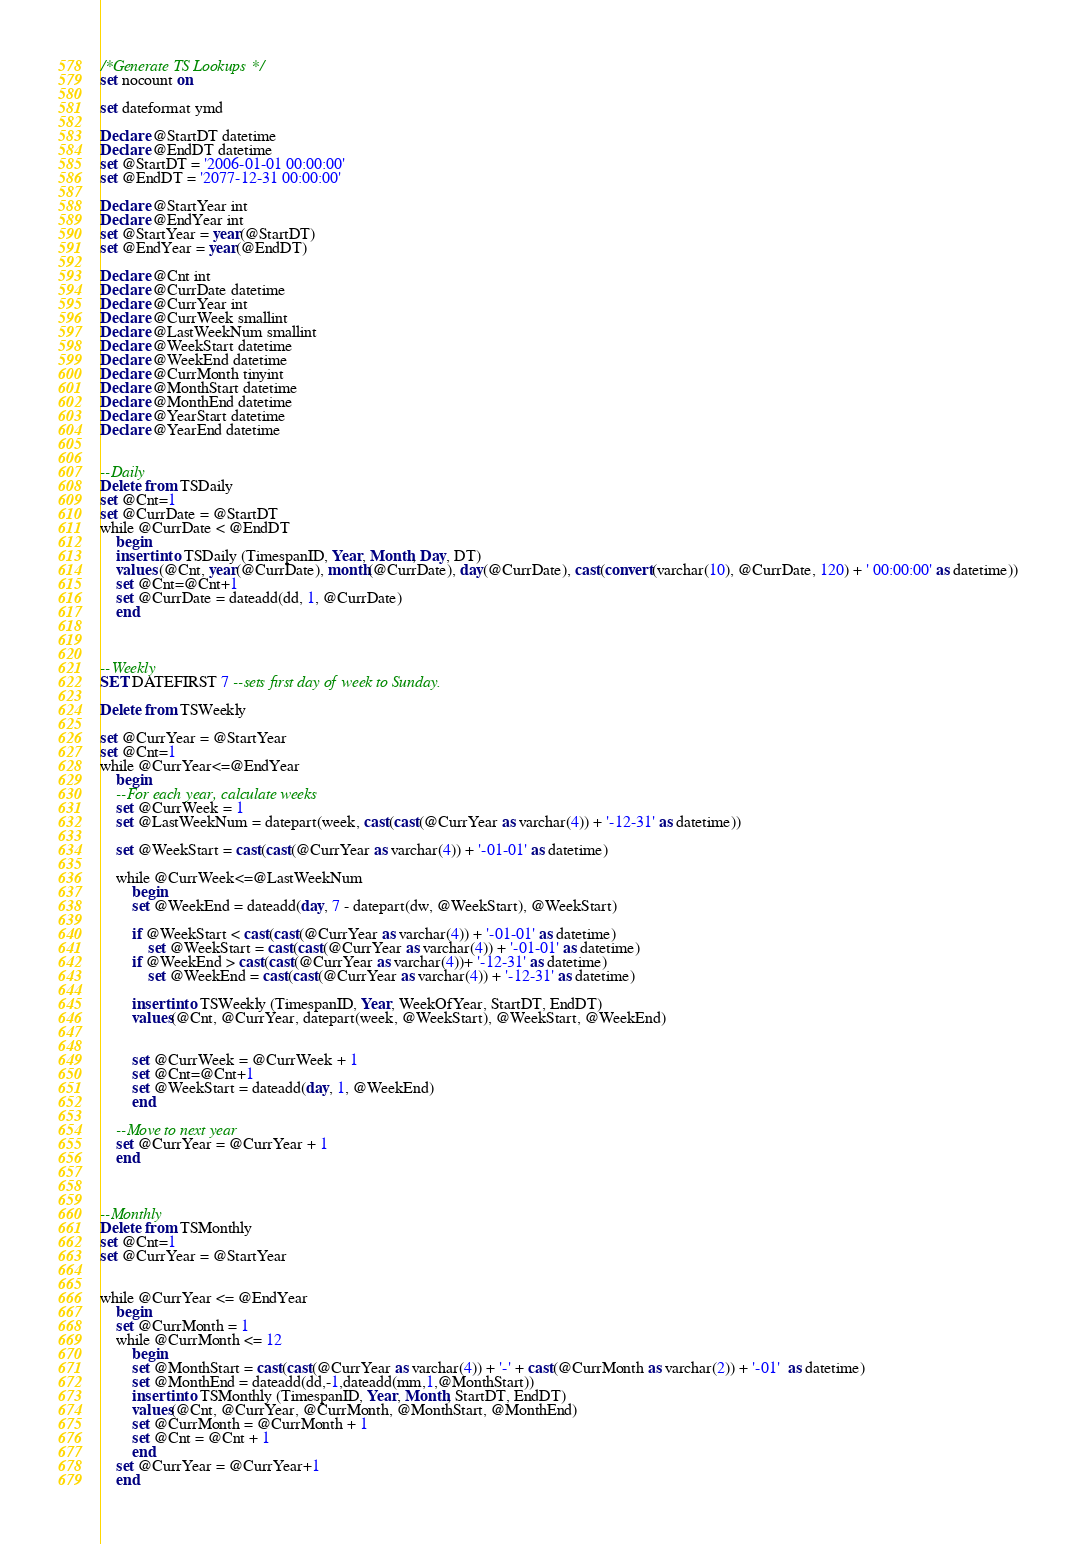Convert code to text. <code><loc_0><loc_0><loc_500><loc_500><_SQL_>/*Generate TS Lookups*/
set nocount on

set dateformat ymd

Declare @StartDT datetime
Declare @EndDT datetime
set @StartDT = '2006-01-01 00:00:00'
set @EndDT = '2077-12-31 00:00:00'

Declare @StartYear int
Declare @EndYear int
set @StartYear = year(@StartDT)
set @EndYear = year(@EndDT)

Declare @Cnt int
Declare @CurrDate datetime
Declare @CurrYear int
Declare @CurrWeek smallint
Declare @LastWeekNum smallint
Declare @WeekStart datetime
Declare @WeekEnd datetime
Declare @CurrMonth tinyint
Declare @MonthStart datetime
Declare @MonthEnd datetime
Declare @YearStart datetime
Declare @YearEnd datetime


--Daily
Delete from TSDaily
set @Cnt=1
set @CurrDate = @StartDT
while @CurrDate < @EndDT
	begin
	insert into TSDaily (TimespanID, Year, Month, Day, DT)
	values (@Cnt, year(@CurrDate), month(@CurrDate), day(@CurrDate), cast(convert(varchar(10), @CurrDate, 120) + ' 00:00:00' as datetime))
	set @Cnt=@Cnt+1
	set @CurrDate = dateadd(dd, 1, @CurrDate)
	end



--Weekly
SET DATEFIRST 7 --sets first day of week to Sunday.

Delete from TSWeekly

set @CurrYear = @StartYear
set @Cnt=1
while @CurrYear<=@EndYear
	begin
	--For each year, calculate weeks
	set @CurrWeek = 1
	set @LastWeekNum = datepart(week, cast(cast(@CurrYear as varchar(4)) + '-12-31' as datetime))

	set @WeekStart = cast(cast(@CurrYear as varchar(4)) + '-01-01' as datetime)

	while @CurrWeek<=@LastWeekNum
		begin
		set @WeekEnd = dateadd(day, 7 - datepart(dw, @WeekStart), @WeekStart)

		if @WeekStart < cast(cast(@CurrYear as varchar(4)) + '-01-01' as datetime)
			set @WeekStart = cast(cast(@CurrYear as varchar(4)) + '-01-01' as datetime)
		if @WeekEnd > cast(cast(@CurrYear as varchar(4))+ '-12-31' as datetime)
			set @WeekEnd = cast(cast(@CurrYear as varchar(4)) + '-12-31' as datetime)

		insert into TSWeekly (TimespanID, Year, WeekOfYear, StartDT, EndDT)
		values(@Cnt, @CurrYear, datepart(week, @WeekStart), @WeekStart, @WeekEnd)
		

		set @CurrWeek = @CurrWeek + 1
		set @Cnt=@Cnt+1
		set @WeekStart = dateadd(day, 1, @WeekEnd)
		end

	--Move to next year
	set @CurrYear = @CurrYear + 1
	end



--Monthly
Delete from TSMonthly
set @Cnt=1
set @CurrYear = @StartYear


while @CurrYear <= @EndYear 
	begin
	set @CurrMonth = 1
	while @CurrMonth <= 12
		begin
		set @MonthStart = cast(cast(@CurrYear as varchar(4)) + '-' + cast(@CurrMonth as varchar(2)) + '-01'  as datetime)
		set @MonthEnd = dateadd(dd,-1,dateadd(mm,1,@MonthStart))
		insert into TSMonthly (TimespanID, Year, Month, StartDT, EndDT)
		values(@Cnt, @CurrYear, @CurrMonth, @MonthStart, @MonthEnd)
		set @CurrMonth = @CurrMonth + 1
		set @Cnt = @Cnt + 1
		end
	set @CurrYear = @CurrYear+1
	end


</code> 